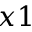<formula> <loc_0><loc_0><loc_500><loc_500>x 1</formula> 